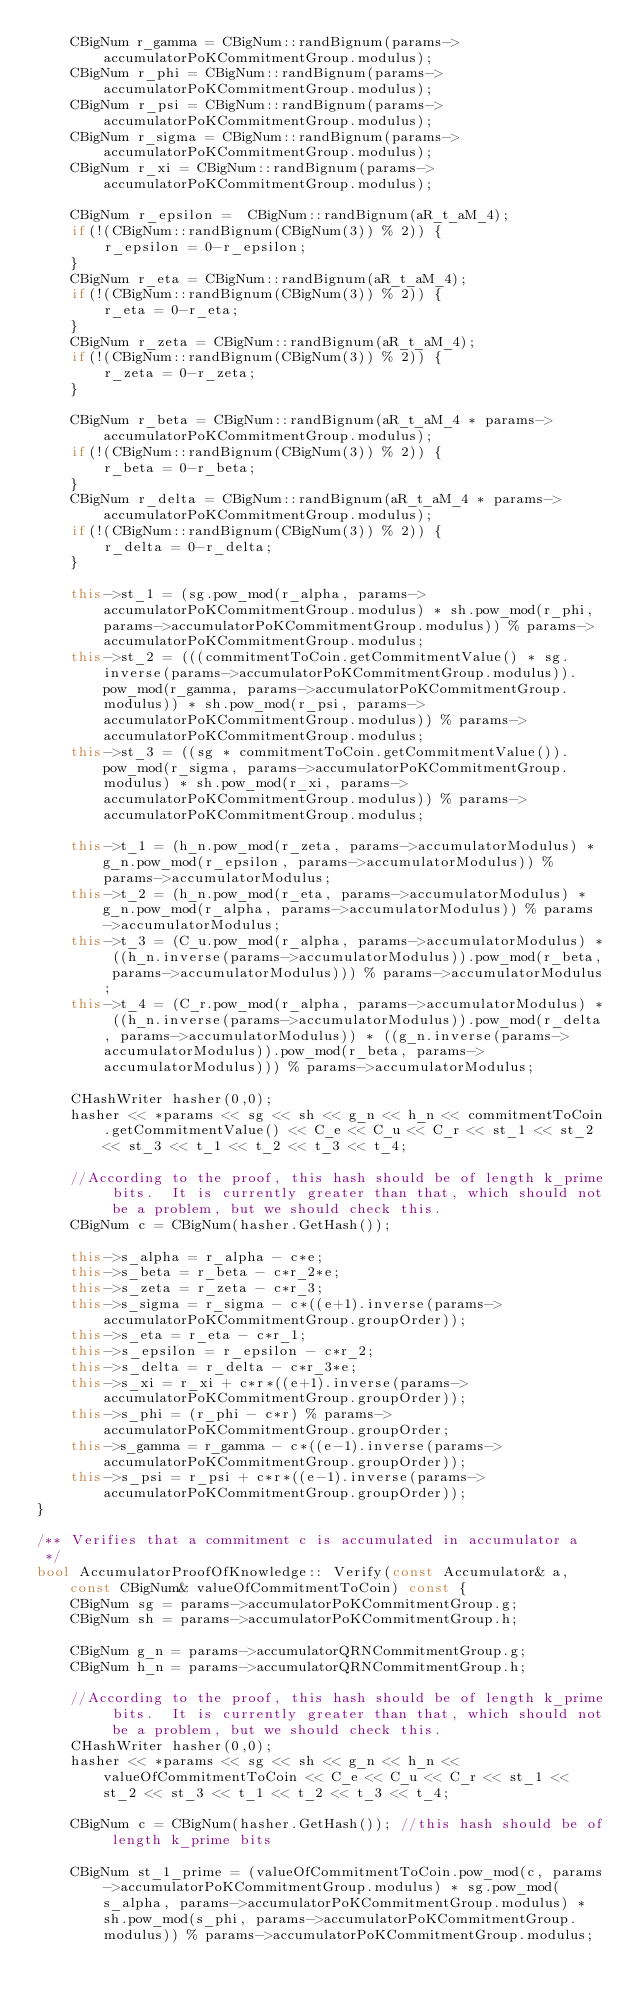<code> <loc_0><loc_0><loc_500><loc_500><_C++_>	CBigNum r_gamma = CBigNum::randBignum(params->accumulatorPoKCommitmentGroup.modulus);
	CBigNum r_phi = CBigNum::randBignum(params->accumulatorPoKCommitmentGroup.modulus);
	CBigNum r_psi = CBigNum::randBignum(params->accumulatorPoKCommitmentGroup.modulus);
	CBigNum r_sigma = CBigNum::randBignum(params->accumulatorPoKCommitmentGroup.modulus);
	CBigNum r_xi = CBigNum::randBignum(params->accumulatorPoKCommitmentGroup.modulus);

    CBigNum r_epsilon =  CBigNum::randBignum(aR_t_aM_4);
	if(!(CBigNum::randBignum(CBigNum(3)) % 2)) {
		r_epsilon = 0-r_epsilon;
	}
    CBigNum r_eta = CBigNum::randBignum(aR_t_aM_4);
	if(!(CBigNum::randBignum(CBigNum(3)) % 2)) {
		r_eta = 0-r_eta;
	}
    CBigNum r_zeta = CBigNum::randBignum(aR_t_aM_4);
	if(!(CBigNum::randBignum(CBigNum(3)) % 2)) {
		r_zeta = 0-r_zeta;
	}

    CBigNum r_beta = CBigNum::randBignum(aR_t_aM_4 * params->accumulatorPoKCommitmentGroup.modulus);
	if(!(CBigNum::randBignum(CBigNum(3)) % 2)) {
		r_beta = 0-r_beta;
	}
    CBigNum r_delta = CBigNum::randBignum(aR_t_aM_4 * params->accumulatorPoKCommitmentGroup.modulus);
	if(!(CBigNum::randBignum(CBigNum(3)) % 2)) {
		r_delta = 0-r_delta;
	}

	this->st_1 = (sg.pow_mod(r_alpha, params->accumulatorPoKCommitmentGroup.modulus) * sh.pow_mod(r_phi, params->accumulatorPoKCommitmentGroup.modulus)) % params->accumulatorPoKCommitmentGroup.modulus;
	this->st_2 = (((commitmentToCoin.getCommitmentValue() * sg.inverse(params->accumulatorPoKCommitmentGroup.modulus)).pow_mod(r_gamma, params->accumulatorPoKCommitmentGroup.modulus)) * sh.pow_mod(r_psi, params->accumulatorPoKCommitmentGroup.modulus)) % params->accumulatorPoKCommitmentGroup.modulus;
	this->st_3 = ((sg * commitmentToCoin.getCommitmentValue()).pow_mod(r_sigma, params->accumulatorPoKCommitmentGroup.modulus) * sh.pow_mod(r_xi, params->accumulatorPoKCommitmentGroup.modulus)) % params->accumulatorPoKCommitmentGroup.modulus;

	this->t_1 = (h_n.pow_mod(r_zeta, params->accumulatorModulus) * g_n.pow_mod(r_epsilon, params->accumulatorModulus)) % params->accumulatorModulus;
	this->t_2 = (h_n.pow_mod(r_eta, params->accumulatorModulus) * g_n.pow_mod(r_alpha, params->accumulatorModulus)) % params->accumulatorModulus;
	this->t_3 = (C_u.pow_mod(r_alpha, params->accumulatorModulus) * ((h_n.inverse(params->accumulatorModulus)).pow_mod(r_beta, params->accumulatorModulus))) % params->accumulatorModulus;
	this->t_4 = (C_r.pow_mod(r_alpha, params->accumulatorModulus) * ((h_n.inverse(params->accumulatorModulus)).pow_mod(r_delta, params->accumulatorModulus)) * ((g_n.inverse(params->accumulatorModulus)).pow_mod(r_beta, params->accumulatorModulus))) % params->accumulatorModulus;

	CHashWriter hasher(0,0);
	hasher << *params << sg << sh << g_n << h_n << commitmentToCoin.getCommitmentValue() << C_e << C_u << C_r << st_1 << st_2 << st_3 << t_1 << t_2 << t_3 << t_4;

	//According to the proof, this hash should be of length k_prime bits.  It is currently greater than that, which should not be a problem, but we should check this.
	CBigNum c = CBigNum(hasher.GetHash());

	this->s_alpha = r_alpha - c*e;
	this->s_beta = r_beta - c*r_2*e;
	this->s_zeta = r_zeta - c*r_3;
	this->s_sigma = r_sigma - c*((e+1).inverse(params->accumulatorPoKCommitmentGroup.groupOrder));
	this->s_eta = r_eta - c*r_1;
	this->s_epsilon = r_epsilon - c*r_2;
	this->s_delta = r_delta - c*r_3*e;
	this->s_xi = r_xi + c*r*((e+1).inverse(params->accumulatorPoKCommitmentGroup.groupOrder));
	this->s_phi = (r_phi - c*r) % params->accumulatorPoKCommitmentGroup.groupOrder;
	this->s_gamma = r_gamma - c*((e-1).inverse(params->accumulatorPoKCommitmentGroup.groupOrder));
	this->s_psi = r_psi + c*r*((e-1).inverse(params->accumulatorPoKCommitmentGroup.groupOrder));
}

/** Verifies that a commitment c is accumulated in accumulator a
 */
bool AccumulatorProofOfKnowledge:: Verify(const Accumulator& a, const CBigNum& valueOfCommitmentToCoin) const {
	CBigNum sg = params->accumulatorPoKCommitmentGroup.g;
	CBigNum sh = params->accumulatorPoKCommitmentGroup.h;

	CBigNum g_n = params->accumulatorQRNCommitmentGroup.g;
	CBigNum h_n = params->accumulatorQRNCommitmentGroup.h;

	//According to the proof, this hash should be of length k_prime bits.  It is currently greater than that, which should not be a problem, but we should check this.
	CHashWriter hasher(0,0);
	hasher << *params << sg << sh << g_n << h_n << valueOfCommitmentToCoin << C_e << C_u << C_r << st_1 << st_2 << st_3 << t_1 << t_2 << t_3 << t_4;

	CBigNum c = CBigNum(hasher.GetHash()); //this hash should be of length k_prime bits

	CBigNum st_1_prime = (valueOfCommitmentToCoin.pow_mod(c, params->accumulatorPoKCommitmentGroup.modulus) * sg.pow_mod(s_alpha, params->accumulatorPoKCommitmentGroup.modulus) * sh.pow_mod(s_phi, params->accumulatorPoKCommitmentGroup.modulus)) % params->accumulatorPoKCommitmentGroup.modulus;</code> 